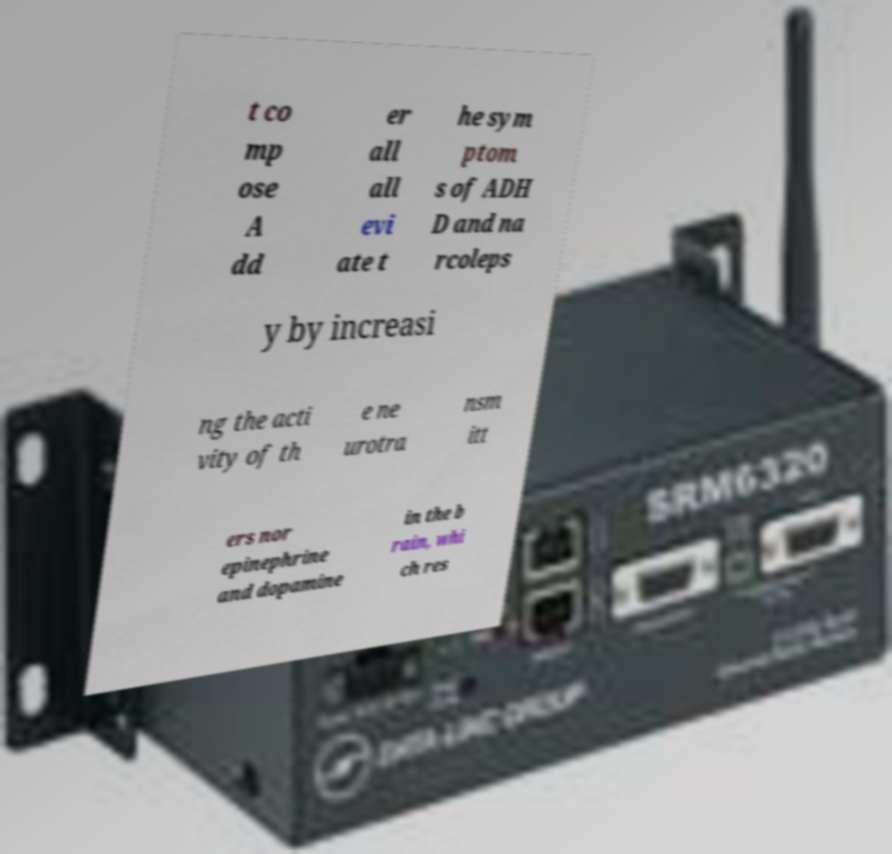I need the written content from this picture converted into text. Can you do that? t co mp ose A dd er all all evi ate t he sym ptom s of ADH D and na rcoleps y by increasi ng the acti vity of th e ne urotra nsm itt ers nor epinephrine and dopamine in the b rain, whi ch res 